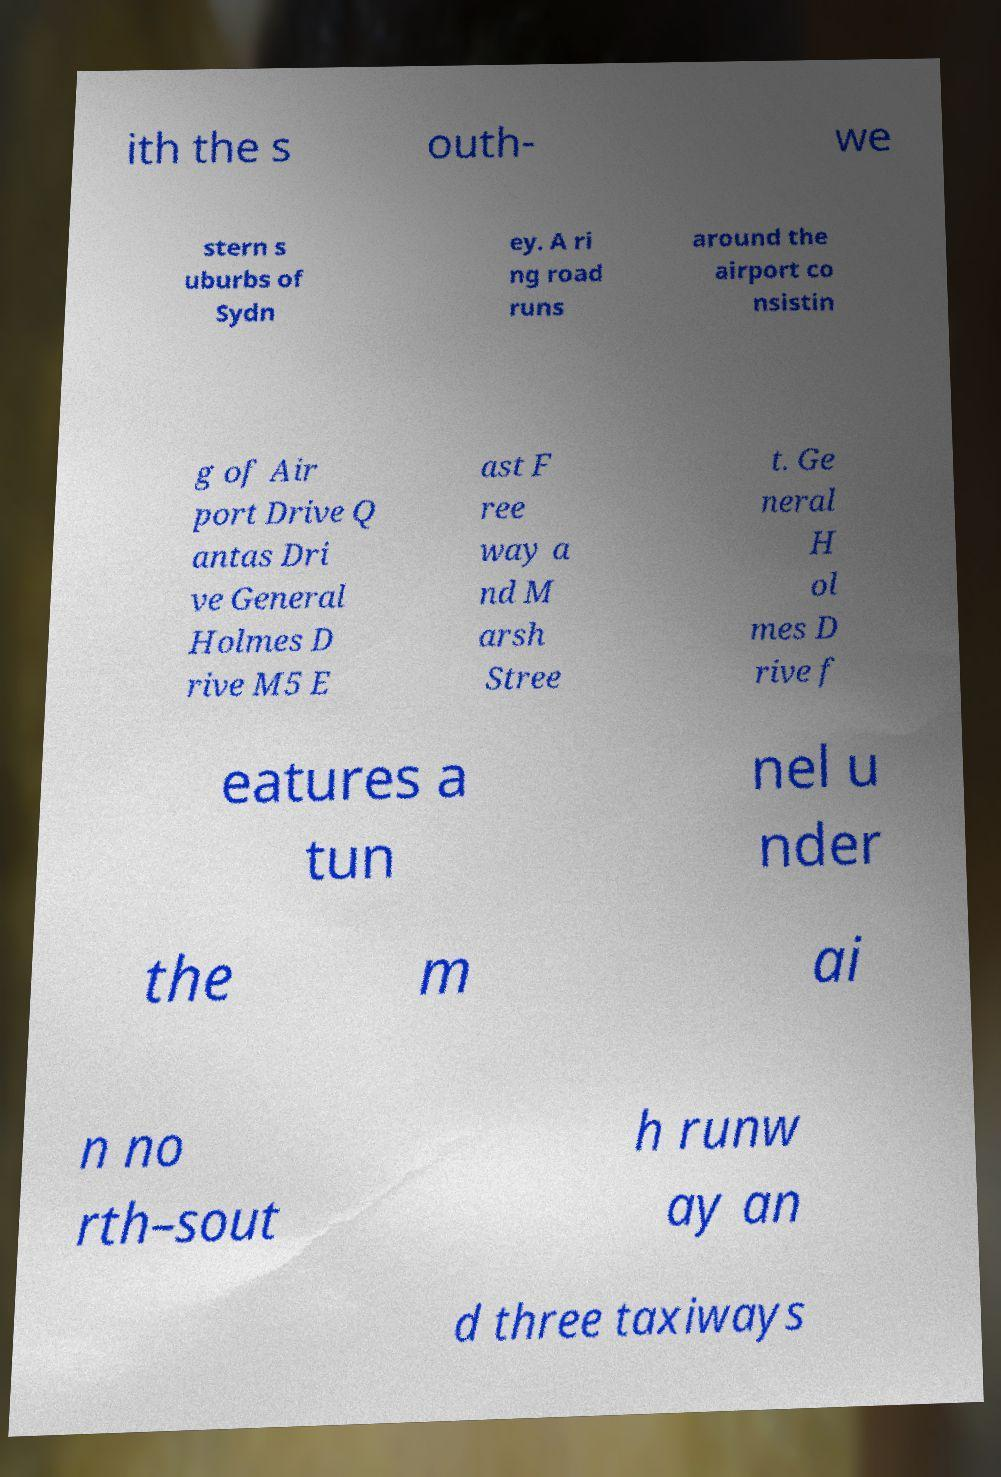Please read and relay the text visible in this image. What does it say? ith the s outh- we stern s uburbs of Sydn ey. A ri ng road runs around the airport co nsistin g of Air port Drive Q antas Dri ve General Holmes D rive M5 E ast F ree way a nd M arsh Stree t. Ge neral H ol mes D rive f eatures a tun nel u nder the m ai n no rth–sout h runw ay an d three taxiways 